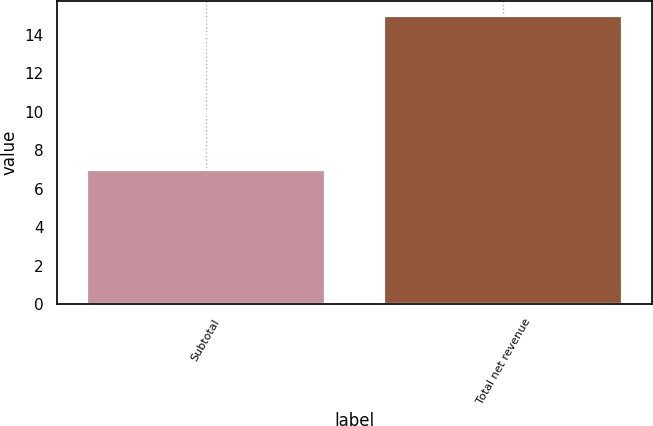Convert chart. <chart><loc_0><loc_0><loc_500><loc_500><bar_chart><fcel>Subtotal<fcel>Total net revenue<nl><fcel>7<fcel>15<nl></chart> 